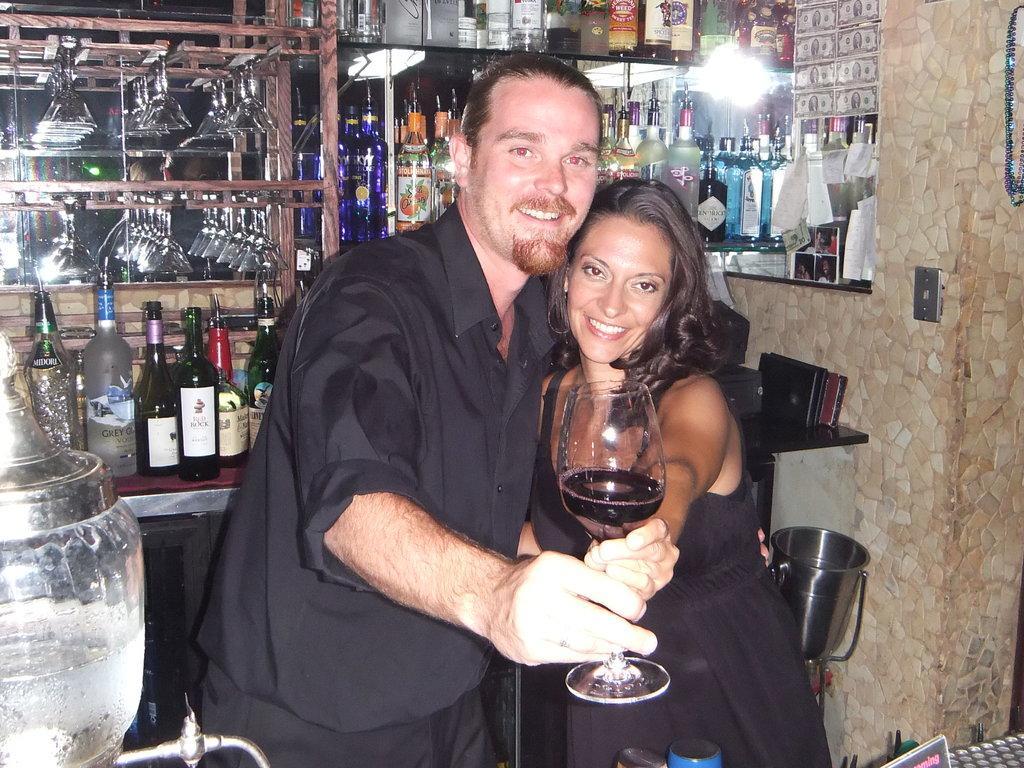How would you summarize this image in a sentence or two? In this picture, we see two people one man and one woman. holding a class with wine and we see bottles back to them 